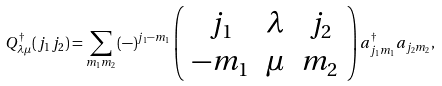Convert formula to latex. <formula><loc_0><loc_0><loc_500><loc_500>Q _ { \lambda \mu } ^ { \dagger } ( j _ { 1 } j _ { 2 } ) = \sum _ { m _ { 1 } m _ { 2 } } ( - ) ^ { j _ { 1 } - m _ { 1 } } \left ( \begin{array} { c c c } j _ { 1 } & \lambda & j _ { 2 } \\ - m _ { 1 } & \mu & m _ { 2 } \end{array} \right ) a _ { j _ { 1 } m _ { 1 } } ^ { \dagger } a _ { j _ { 2 } m _ { 2 } } ,</formula> 